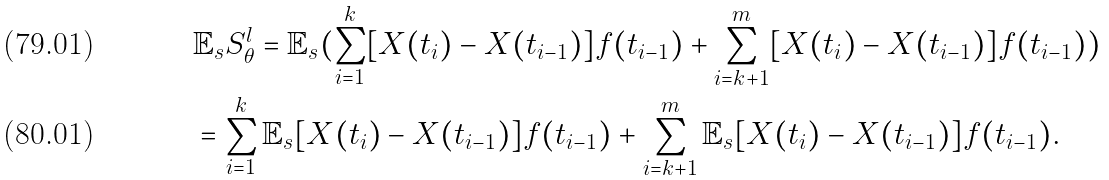Convert formula to latex. <formula><loc_0><loc_0><loc_500><loc_500>& \mathbb { E } _ { s } S _ { \theta } ^ { l } = \mathbb { E } _ { s } ( \sum _ { i = 1 } ^ { k } [ X ( t _ { i } ) - X ( t _ { i - 1 } ) ] f ( t _ { i - 1 } ) + \sum _ { i = k + 1 } ^ { m } [ X ( t _ { i } ) - X ( t _ { i - 1 } ) ] f ( t _ { i - 1 } ) ) \\ & = \sum _ { i = 1 } ^ { k } \mathbb { E } _ { s } [ X ( t _ { i } ) - X ( t _ { i - 1 } ) ] f ( t _ { i - 1 } ) + \sum _ { i = k + 1 } ^ { m } \mathbb { E } _ { s } [ X ( t _ { i } ) - X ( t _ { i - 1 } ) ] f ( t _ { i - 1 } ) .</formula> 